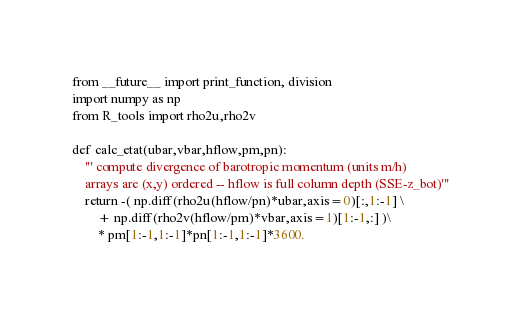<code> <loc_0><loc_0><loc_500><loc_500><_Python_>from __future__ import print_function, division
import numpy as np
from R_tools import rho2u,rho2v

def calc_etat(ubar,vbar,hflow,pm,pn):
    ''' compute divergence of barotropic momentum (units m/h) 
    arrays are (x,y) ordered -- hflow is full column depth (SSE-z_bot)'''
    return -( np.diff(rho2u(hflow/pn)*ubar,axis=0)[:,1:-1] \
        + np.diff(rho2v(hflow/pm)*vbar,axis=1)[1:-1,:] )\
        * pm[1:-1,1:-1]*pn[1:-1,1:-1]*3600.

</code> 